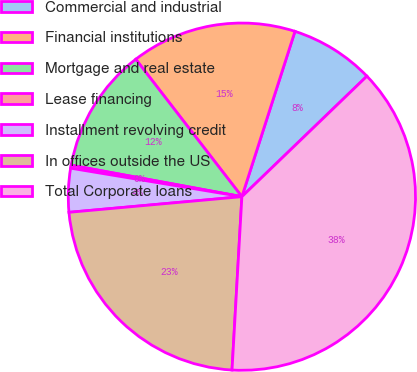Convert chart to OTSL. <chart><loc_0><loc_0><loc_500><loc_500><pie_chart><fcel>Commercial and industrial<fcel>Financial institutions<fcel>Mortgage and real estate<fcel>Lease financing<fcel>Installment revolving credit<fcel>In offices outside the US<fcel>Total Corporate loans<nl><fcel>7.85%<fcel>15.41%<fcel>11.63%<fcel>0.28%<fcel>4.06%<fcel>22.66%<fcel>38.11%<nl></chart> 